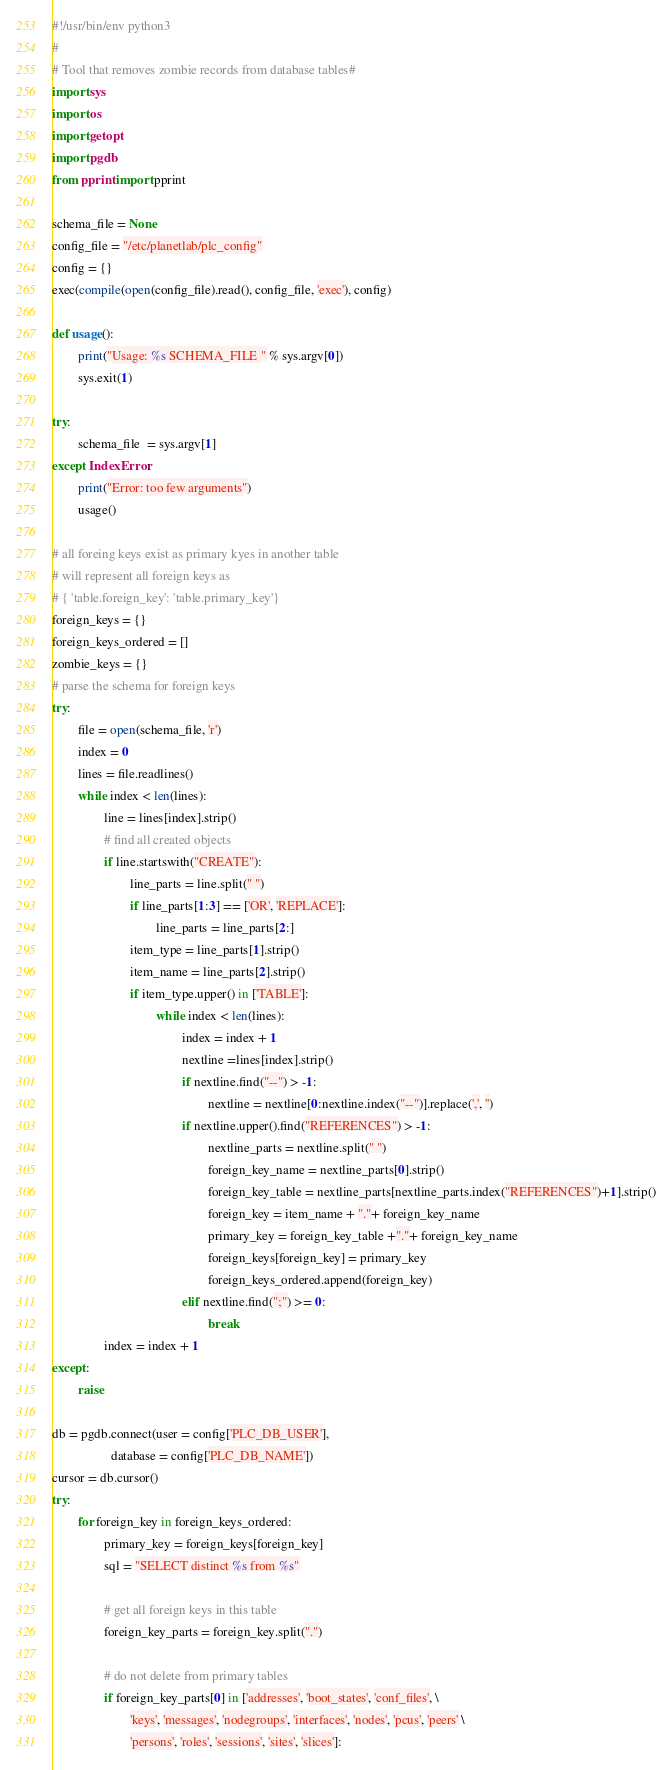<code> <loc_0><loc_0><loc_500><loc_500><_Python_>#!/usr/bin/env python3
#
# Tool that removes zombie records from database tables#
import sys
import os
import getopt
import pgdb
from pprint import pprint

schema_file = None
config_file = "/etc/planetlab/plc_config"
config = {}
exec(compile(open(config_file).read(), config_file, 'exec'), config)

def usage():
        print("Usage: %s SCHEMA_FILE " % sys.argv[0])
        sys.exit(1)

try:
        schema_file  = sys.argv[1]
except IndexError:
        print("Error: too few arguments")
        usage()

# all foreing keys exist as primary kyes in another table
# will represent all foreign keys as
# { 'table.foreign_key': 'table.primary_key'} 
foreign_keys = {}
foreign_keys_ordered = []
zombie_keys = {}
# parse the schema for foreign keys
try:
        file = open(schema_file, 'r')
        index = 0
        lines = file.readlines()
        while index < len(lines):
                line = lines[index].strip()
                # find all created objects
                if line.startswith("CREATE"):
                        line_parts = line.split(" ")
                        if line_parts[1:3] == ['OR', 'REPLACE']:
                                line_parts = line_parts[2:]
                        item_type = line_parts[1].strip()
                        item_name = line_parts[2].strip()
                        if item_type.upper() in ['TABLE']:
                                while index < len(lines):
                                        index = index + 1
                                        nextline =lines[index].strip()
                                        if nextline.find("--") > -1:
                                                nextline = nextline[0:nextline.index("--")].replace(',', '')
                                        if nextline.upper().find("REFERENCES") > -1:
                                                nextline_parts = nextline.split(" ")
                                                foreign_key_name = nextline_parts[0].strip()
                                                foreign_key_table = nextline_parts[nextline_parts.index("REFERENCES")+1].strip()
                                                foreign_key = item_name + "."+ foreign_key_name
                                                primary_key = foreign_key_table +"."+ foreign_key_name 
                                                foreign_keys[foreign_key] = primary_key
                                                foreign_keys_ordered.append(foreign_key)
                                        elif nextline.find(";") >= 0:
                                                break
                index = index + 1
except:
        raise

db = pgdb.connect(user = config['PLC_DB_USER'],
                  database = config['PLC_DB_NAME'])
cursor = db.cursor()
try:
        for foreign_key in foreign_keys_ordered:
                primary_key = foreign_keys[foreign_key]
                sql = "SELECT distinct %s from %s"
                
                # get all foreign keys in this table
                foreign_key_parts = foreign_key.split(".")
        
                # do not delete from primary tables
                if foreign_key_parts[0] in ['addresses', 'boot_states', 'conf_files', \
                        'keys', 'messages', 'nodegroups', 'interfaces', 'nodes', 'pcus', 'peers' \
                        'persons', 'roles', 'sessions', 'sites', 'slices']:</code> 